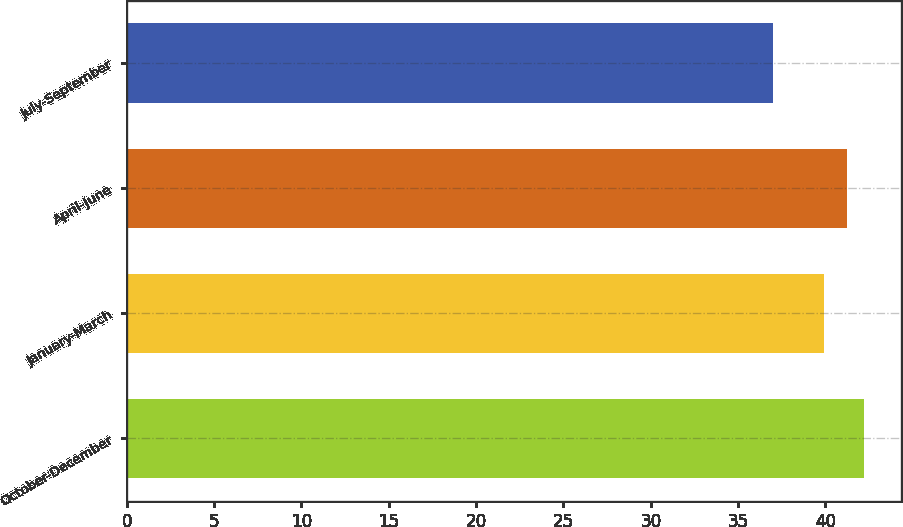<chart> <loc_0><loc_0><loc_500><loc_500><bar_chart><fcel>October-December<fcel>January-March<fcel>April-June<fcel>July-September<nl><fcel>42.23<fcel>39.94<fcel>41.24<fcel>36.99<nl></chart> 